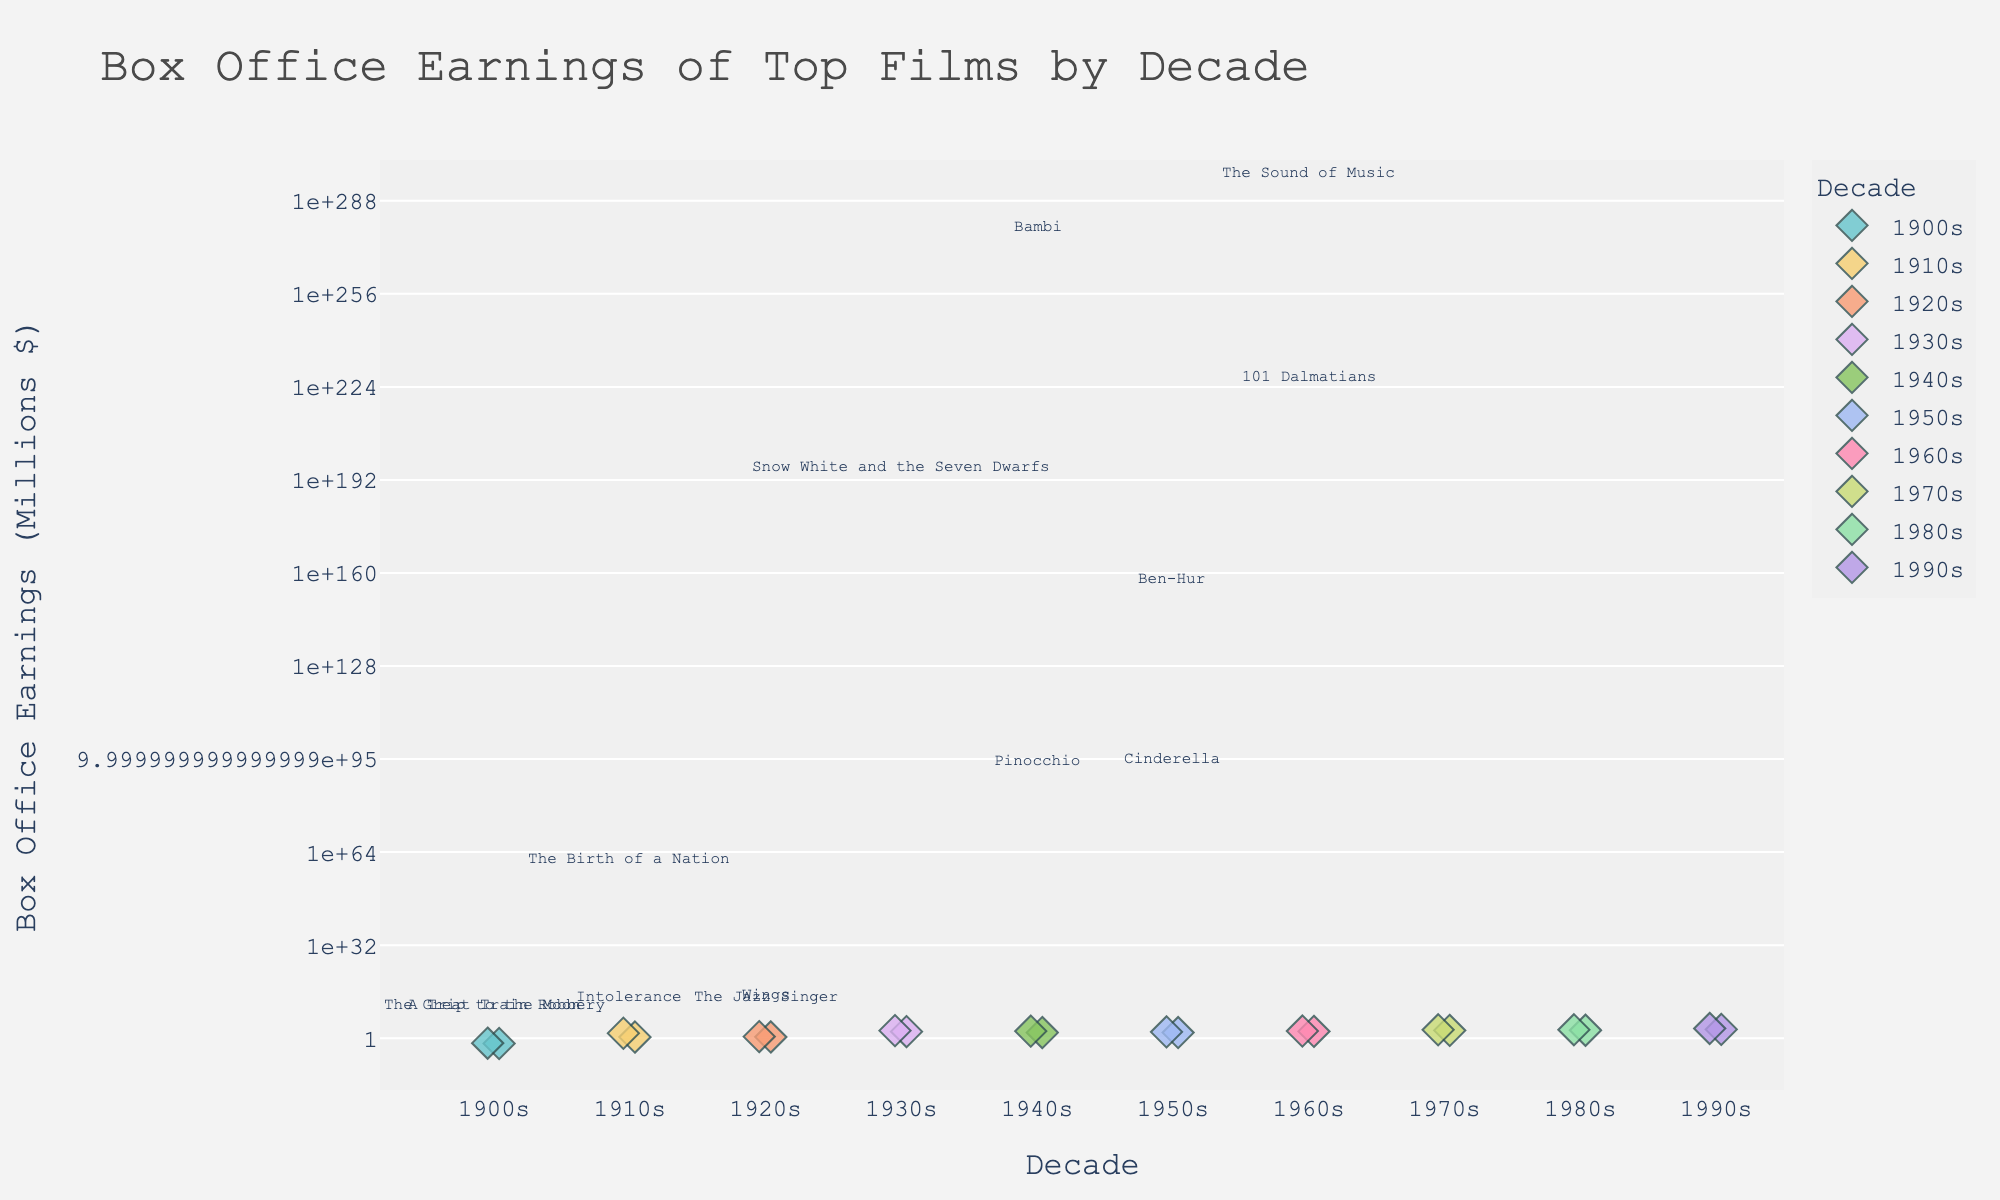What is the title of the figure? Look at the top of the figure where the title is usually located.
Answer: Box Office Earnings of Top Films by Decade Which decade has the highest box office earnings for a single film? Identify the film with the highest box office earnings and check which decade it belongs to.
Answer: 1990s How many films from the 1910s are in the plot? Look for points in the strip plot that are labeled as '1910s'.
Answer: 2 Which films from the 1940s are listed in the plot? Hover over the points labeled as '1940s' to see which films they represent.
Answer: Bambi, Pinocchio Compare the box office earnings of the top films from the 1970s. Which one earned more? Compare the box office earnings of the 1970s' films and see which has a higher value.
Answer: Star Wars What is the approximate box office earnings for 'Gone with the Wind'? Hover over the point representing 'Gone with the Wind' to see its box office earnings.
Answer: $390.525 million Which decade has the smallest range of box office earnings among its listed films? Look at the vertical distribution of points within each decade and see which decade has the shortest range.
Answer: 1900s What's the difference in box office earnings between 'Jurassic Park' and 'E.T. the Extra-Terrestrial'? Find the box office earnings for both films and subtract the smaller amount from the larger one.
Answer: $230.916 million What common characteristic do the 1980s films have in terms of box office earnings compared to previous decades? Look at the pattern of 1980s films' earnings and compare them to earlier decades.
Answer: They have significantly higher earnings What is the median box office earnings for films in the 1950s? List the box office earnings of the 1950s films, sort them in ascending order, and find the middle value.
Answer: $85 million 